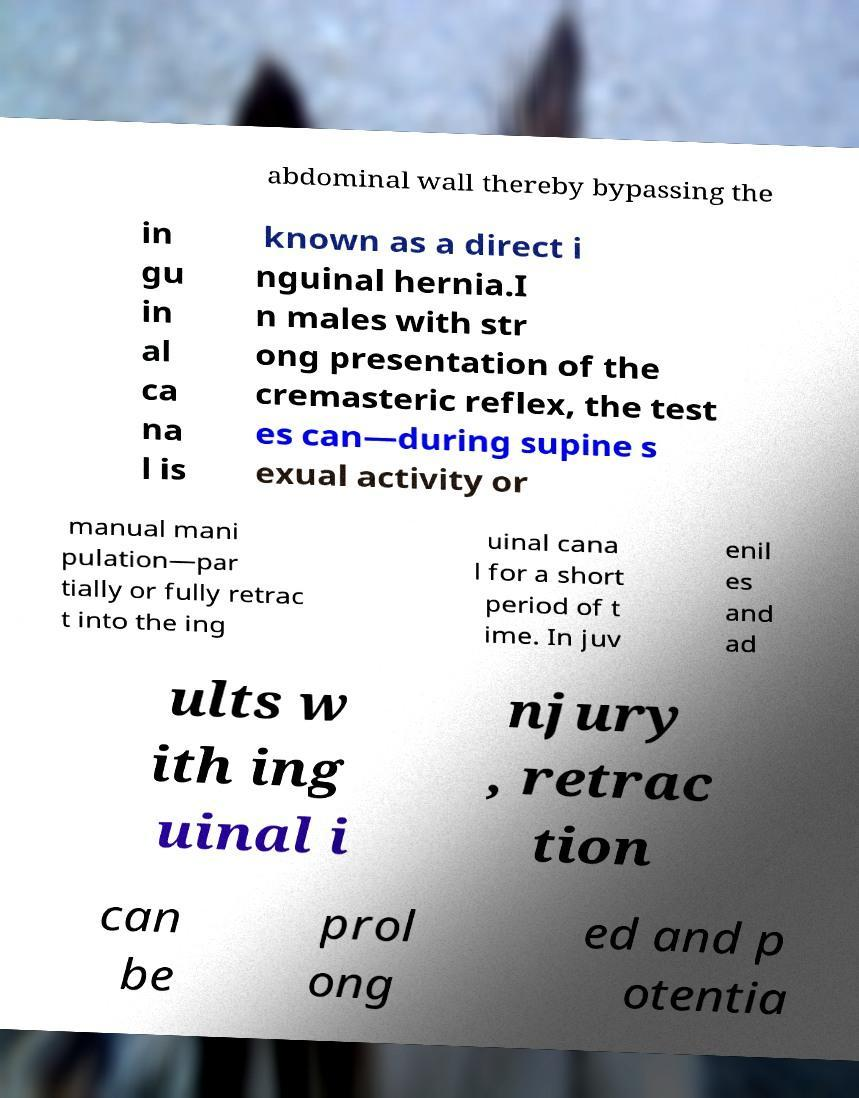Please identify and transcribe the text found in this image. abdominal wall thereby bypassing the in gu in al ca na l is known as a direct i nguinal hernia.I n males with str ong presentation of the cremasteric reflex, the test es can—during supine s exual activity or manual mani pulation—par tially or fully retrac t into the ing uinal cana l for a short period of t ime. In juv enil es and ad ults w ith ing uinal i njury , retrac tion can be prol ong ed and p otentia 